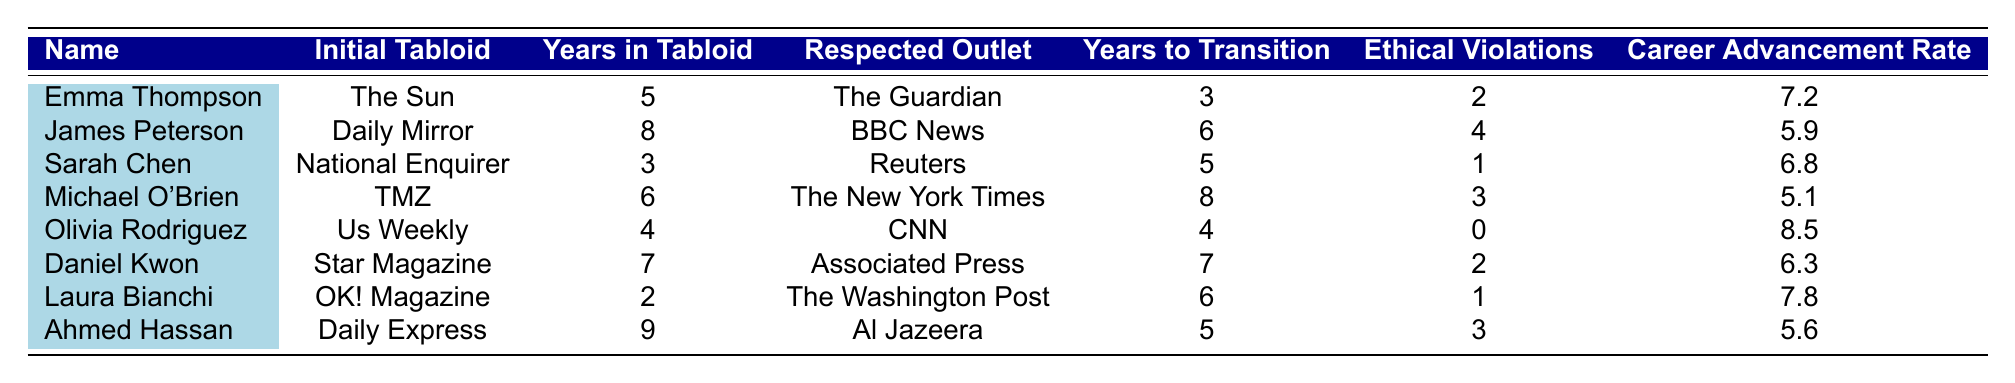What is the name of the journalist who transitioned from "Us Weekly"? Referring to the table, the journalist listed who transitioned from "Us Weekly" is Olivia Rodriguez.
Answer: Olivia Rodriguez How many years did Sarah Chen spend in tabloids? The table shows that Sarah Chen spent 3 years in the National Enquirer.
Answer: 3 years Which respected outlet did James Peterson move to after the Daily Mirror? According to the table, James Peterson transitioned to BBC News after his time at the Daily Mirror.
Answer: BBC News How many ethical violations did Michael O'Brien report? From the table, it indicates that Michael O'Brien reported 3 ethical violations during his career.
Answer: 3 What is the career advancement rate of Olivia Rodriguez? The table lists that Olivia Rodriguez has a career advancement rate of 8.5.
Answer: 8.5 What is the difference in years spent in tabloids between Emma Thompson and Daniel Kwon? Emma Thompson spent 5 years in tabloids while Daniel Kwon spent 7 years, so the difference is 7 - 5 = 2 years.
Answer: 2 years Which journalist reported the least number of ethical violations and how many were there? Upon reviewing the table, Olivia Rodriguez reported 0 ethical violations, the least among all.
Answer: 0 Who had the highest career advancement rate among the journalists listed? The table shows that Olivia Rodriguez has the highest career advancement rate of 8.5, which is greater than the others.
Answer: Olivia Rodriguez If we average the years in tabloids for all journalists, what is the result? Adding the years in tabloids (5 + 8 + 3 + 6 + 4 + 7 + 2 + 9 = 44) gives 44 total years. There are 8 journalists, so the average is 44 / 8 = 5.5 years.
Answer: 5.5 years Is it true that all journalists who transitioned had more than 2 reported ethical violations? Checking the table reveals that both Olivia Rodriguez and Sarah Chen had fewer than 2 reported ethical violations (0 and 1, respectively), thus making the statement false.
Answer: No 